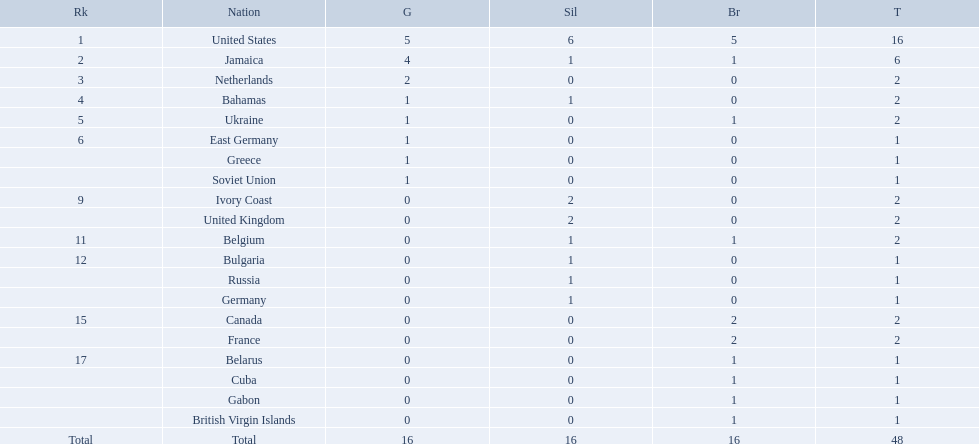What was the largest number of medals won by any country? 16. Which country won that many medals? United States. 